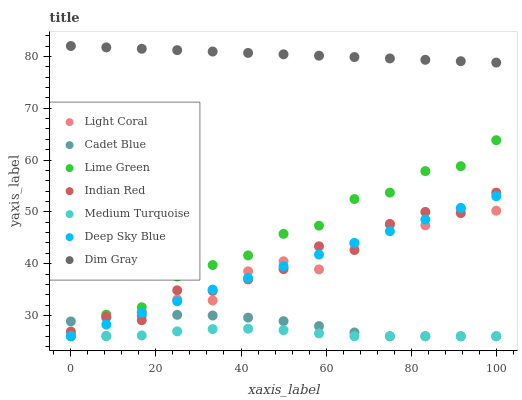Does Medium Turquoise have the minimum area under the curve?
Answer yes or no. Yes. Does Dim Gray have the maximum area under the curve?
Answer yes or no. Yes. Does Light Coral have the minimum area under the curve?
Answer yes or no. No. Does Light Coral have the maximum area under the curve?
Answer yes or no. No. Is Deep Sky Blue the smoothest?
Answer yes or no. Yes. Is Light Coral the roughest?
Answer yes or no. Yes. Is Medium Turquoise the smoothest?
Answer yes or no. No. Is Medium Turquoise the roughest?
Answer yes or no. No. Does Cadet Blue have the lowest value?
Answer yes or no. Yes. Does Light Coral have the lowest value?
Answer yes or no. No. Does Dim Gray have the highest value?
Answer yes or no. Yes. Does Light Coral have the highest value?
Answer yes or no. No. Is Lime Green less than Dim Gray?
Answer yes or no. Yes. Is Light Coral greater than Medium Turquoise?
Answer yes or no. Yes. Does Light Coral intersect Indian Red?
Answer yes or no. Yes. Is Light Coral less than Indian Red?
Answer yes or no. No. Is Light Coral greater than Indian Red?
Answer yes or no. No. Does Lime Green intersect Dim Gray?
Answer yes or no. No. 